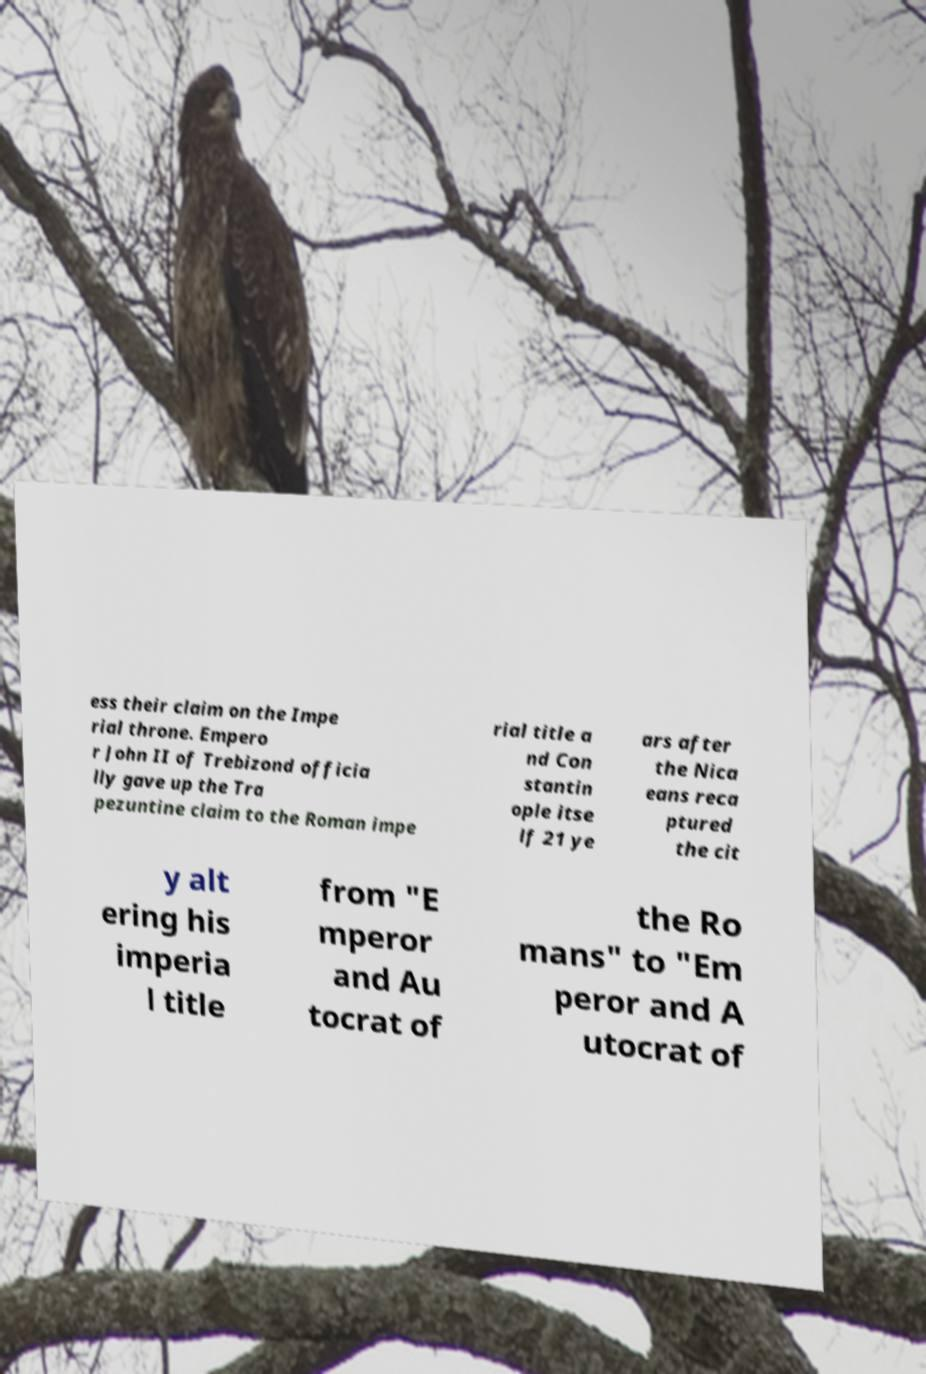Can you read and provide the text displayed in the image?This photo seems to have some interesting text. Can you extract and type it out for me? ess their claim on the Impe rial throne. Empero r John II of Trebizond officia lly gave up the Tra pezuntine claim to the Roman impe rial title a nd Con stantin ople itse lf 21 ye ars after the Nica eans reca ptured the cit y alt ering his imperia l title from "E mperor and Au tocrat of the Ro mans" to "Em peror and A utocrat of 